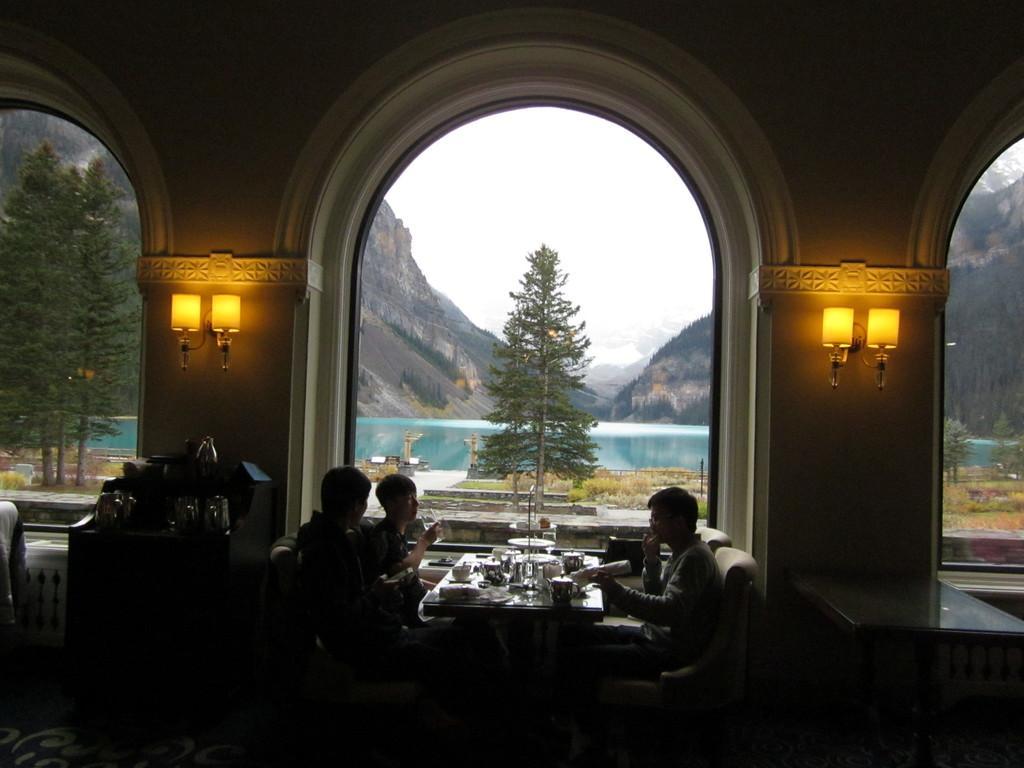Describe this image in one or two sentences. In this image we can see tables. And three persons are sitting on chairs. On the table there are many items. There is another table with jugs and some other items. There are arches. Also there are lights on the wall. In the back we can see trees, water, hills and sky. 